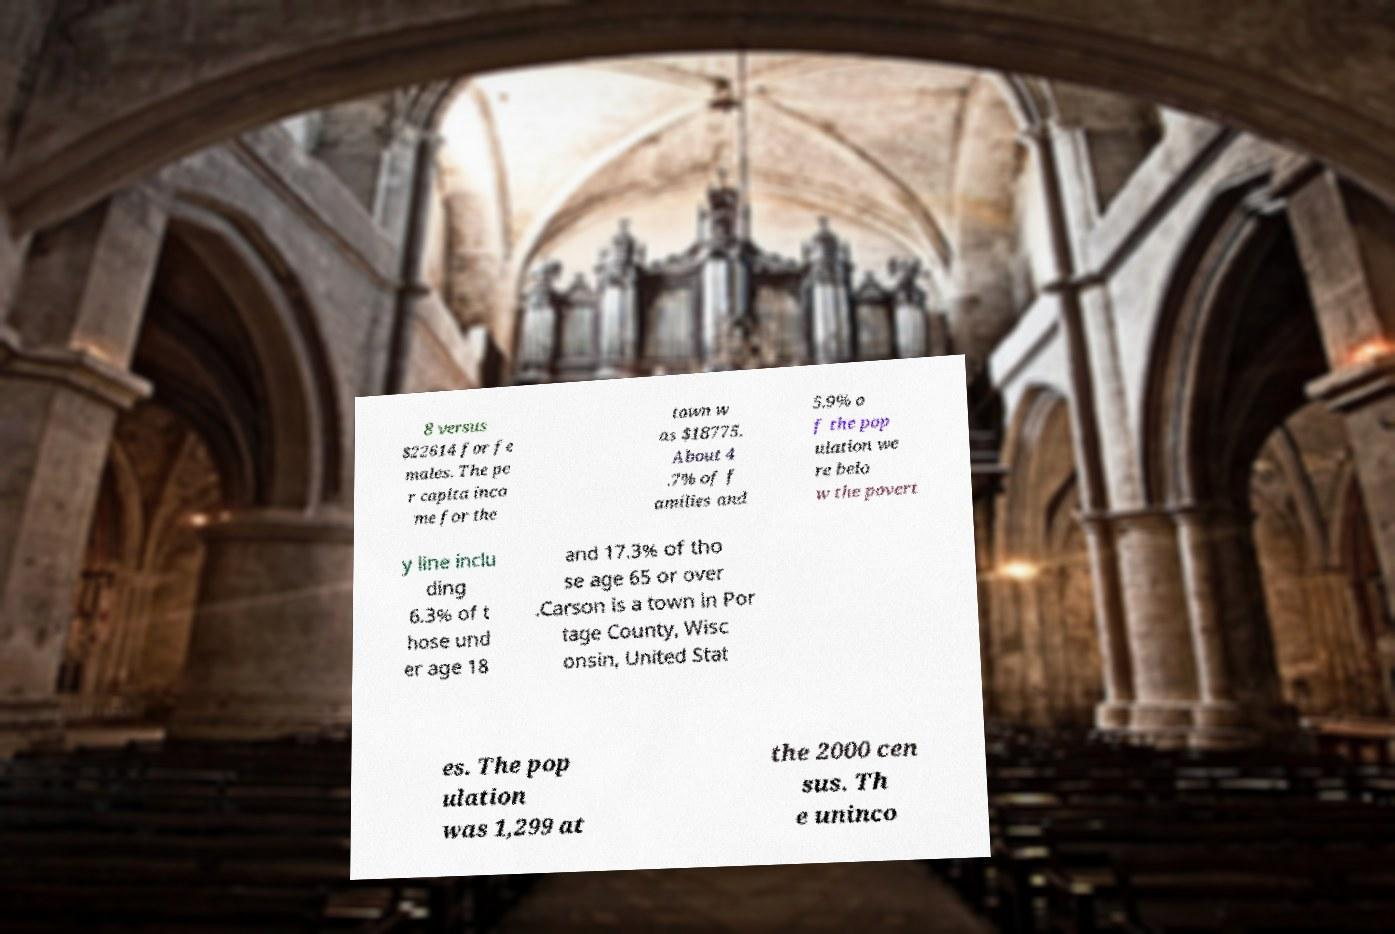Can you read and provide the text displayed in the image?This photo seems to have some interesting text. Can you extract and type it out for me? 8 versus $22614 for fe males. The pe r capita inco me for the town w as $18775. About 4 .7% of f amilies and 5.9% o f the pop ulation we re belo w the povert y line inclu ding 6.3% of t hose und er age 18 and 17.3% of tho se age 65 or over .Carson is a town in Por tage County, Wisc onsin, United Stat es. The pop ulation was 1,299 at the 2000 cen sus. Th e uninco 